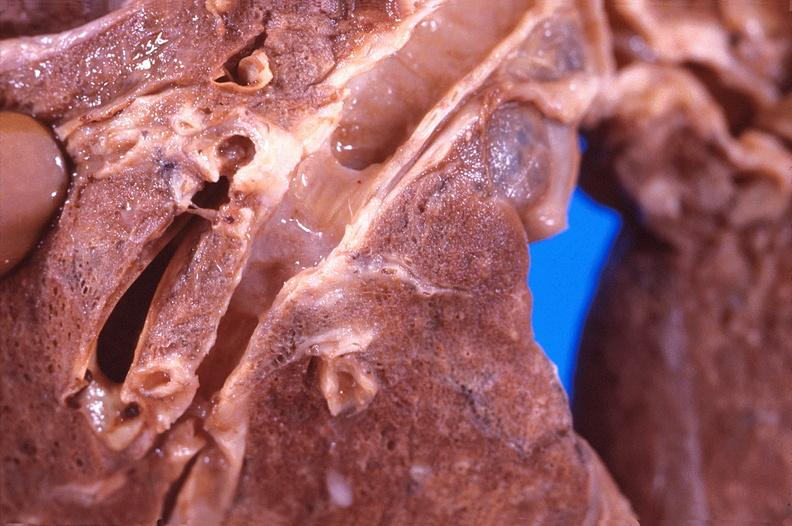s postpartum present?
Answer the question using a single word or phrase. No 